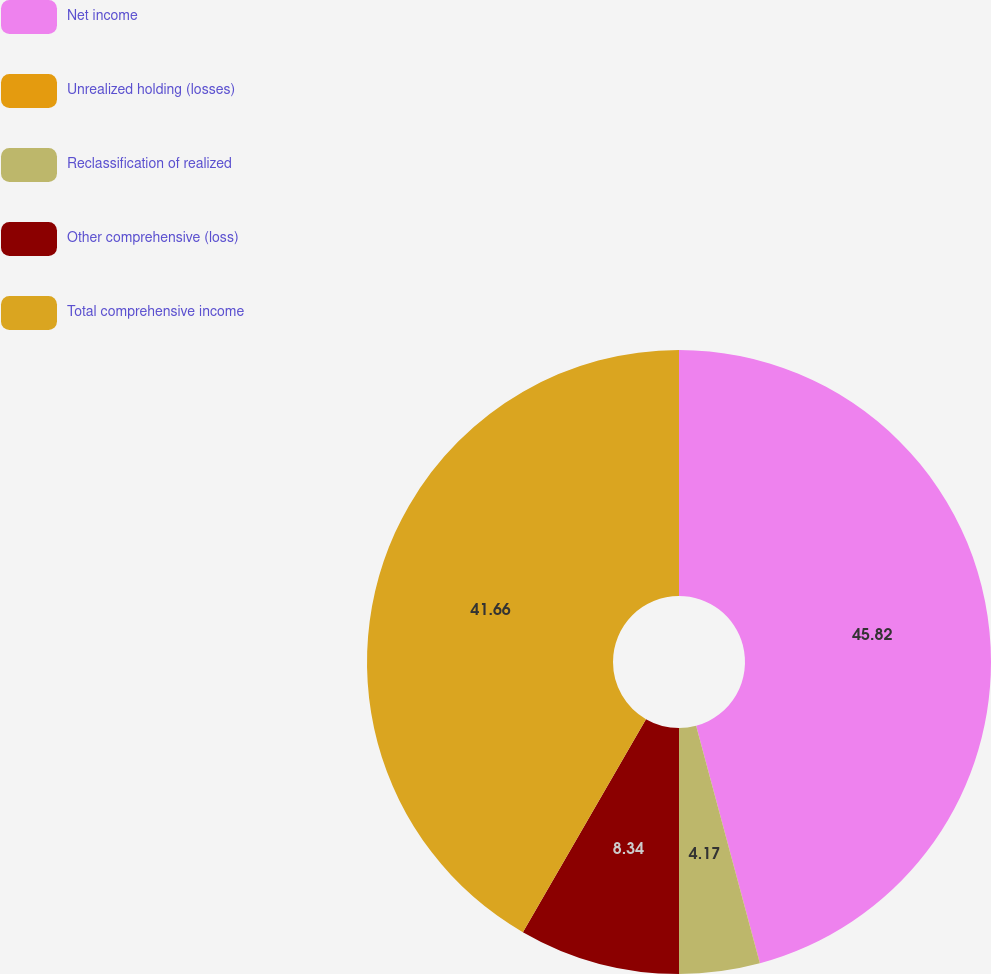<chart> <loc_0><loc_0><loc_500><loc_500><pie_chart><fcel>Net income<fcel>Unrealized holding (losses)<fcel>Reclassification of realized<fcel>Other comprehensive (loss)<fcel>Total comprehensive income<nl><fcel>45.82%<fcel>0.01%<fcel>4.17%<fcel>8.34%<fcel>41.66%<nl></chart> 